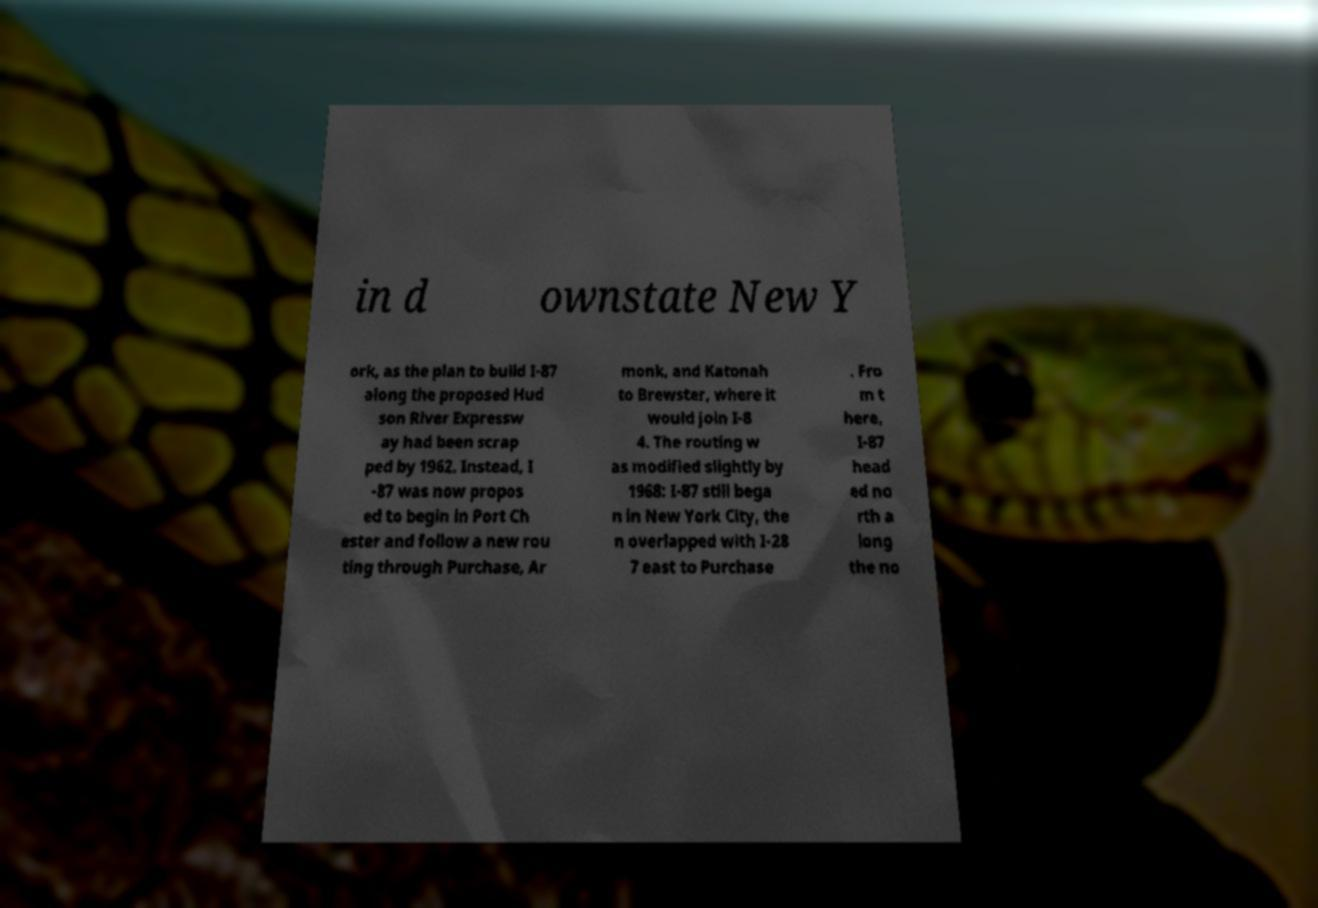Could you assist in decoding the text presented in this image and type it out clearly? in d ownstate New Y ork, as the plan to build I-87 along the proposed Hud son River Expressw ay had been scrap ped by 1962. Instead, I -87 was now propos ed to begin in Port Ch ester and follow a new rou ting through Purchase, Ar monk, and Katonah to Brewster, where it would join I-8 4. The routing w as modified slightly by 1968: I-87 still bega n in New York City, the n overlapped with I-28 7 east to Purchase . Fro m t here, I-87 head ed no rth a long the no 